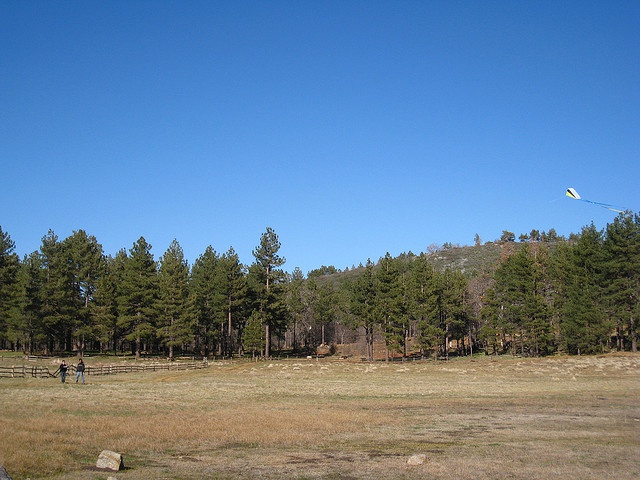Describe the objects in this image and their specific colors. I can see people in blue, black, gray, and tan tones, kite in blue, white, lightblue, and khaki tones, and people in blue, black, and gray tones in this image. 